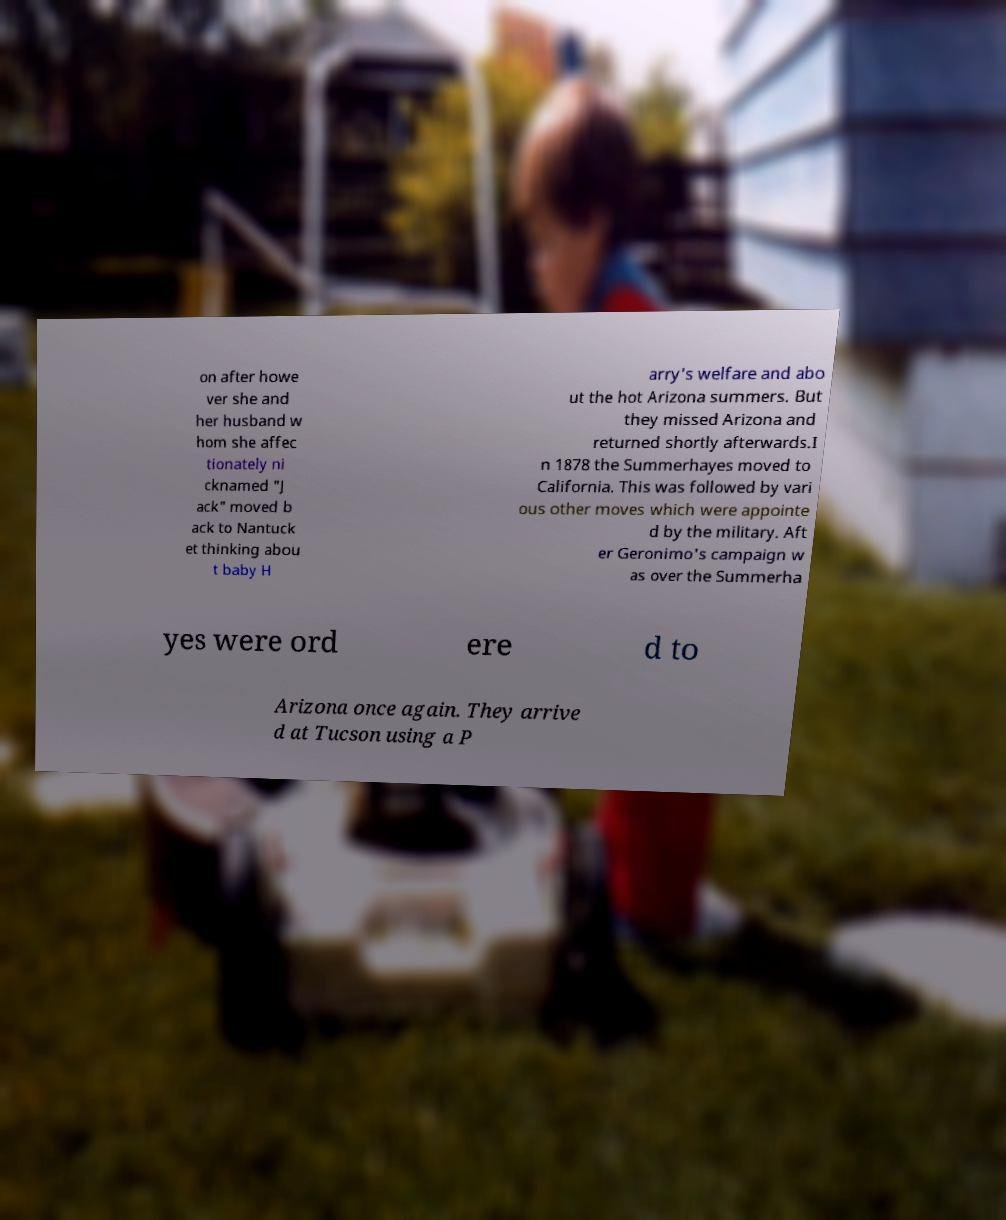Can you read and provide the text displayed in the image?This photo seems to have some interesting text. Can you extract and type it out for me? on after howe ver she and her husband w hom she affec tionately ni cknamed "J ack" moved b ack to Nantuck et thinking abou t baby H arry's welfare and abo ut the hot Arizona summers. But they missed Arizona and returned shortly afterwards.I n 1878 the Summerhayes moved to California. This was followed by vari ous other moves which were appointe d by the military. Aft er Geronimo's campaign w as over the Summerha yes were ord ere d to Arizona once again. They arrive d at Tucson using a P 